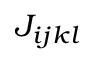<formula> <loc_0><loc_0><loc_500><loc_500>J _ { i j k l }</formula> 